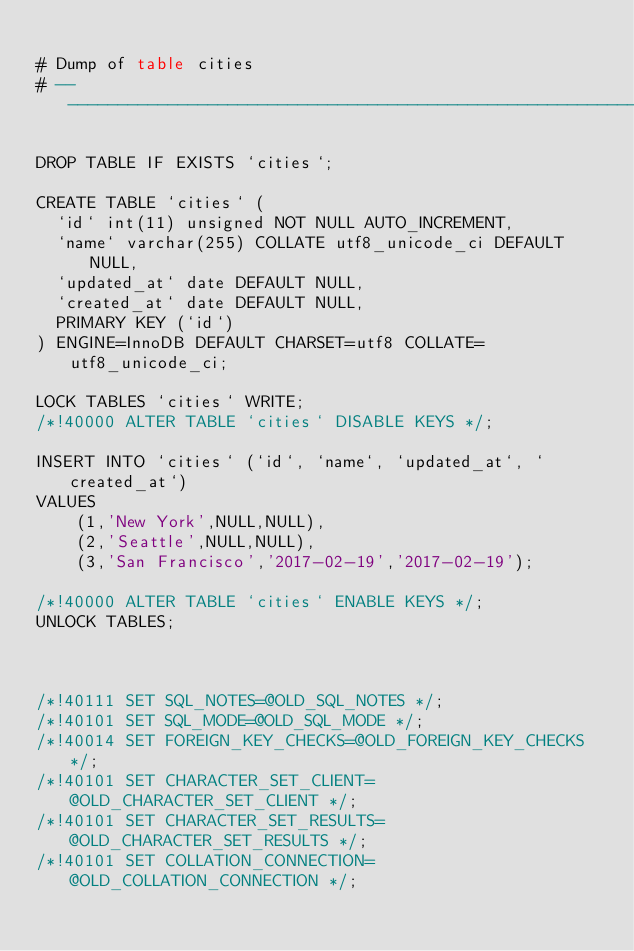Convert code to text. <code><loc_0><loc_0><loc_500><loc_500><_SQL_>
# Dump of table cities
# ------------------------------------------------------------

DROP TABLE IF EXISTS `cities`;

CREATE TABLE `cities` (
  `id` int(11) unsigned NOT NULL AUTO_INCREMENT,
  `name` varchar(255) COLLATE utf8_unicode_ci DEFAULT NULL,
  `updated_at` date DEFAULT NULL,
  `created_at` date DEFAULT NULL,
  PRIMARY KEY (`id`)
) ENGINE=InnoDB DEFAULT CHARSET=utf8 COLLATE=utf8_unicode_ci;

LOCK TABLES `cities` WRITE;
/*!40000 ALTER TABLE `cities` DISABLE KEYS */;

INSERT INTO `cities` (`id`, `name`, `updated_at`, `created_at`)
VALUES
	(1,'New York',NULL,NULL),
	(2,'Seattle',NULL,NULL),
	(3,'San Francisco','2017-02-19','2017-02-19');

/*!40000 ALTER TABLE `cities` ENABLE KEYS */;
UNLOCK TABLES;



/*!40111 SET SQL_NOTES=@OLD_SQL_NOTES */;
/*!40101 SET SQL_MODE=@OLD_SQL_MODE */;
/*!40014 SET FOREIGN_KEY_CHECKS=@OLD_FOREIGN_KEY_CHECKS */;
/*!40101 SET CHARACTER_SET_CLIENT=@OLD_CHARACTER_SET_CLIENT */;
/*!40101 SET CHARACTER_SET_RESULTS=@OLD_CHARACTER_SET_RESULTS */;
/*!40101 SET COLLATION_CONNECTION=@OLD_COLLATION_CONNECTION */;
</code> 